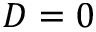<formula> <loc_0><loc_0><loc_500><loc_500>D = 0</formula> 